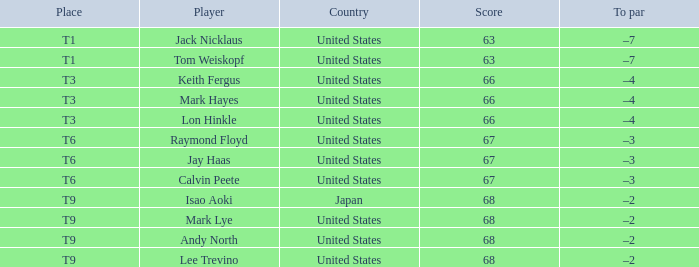For the player "lee trevino" representing the "united states", what is the overall score? 1.0. 